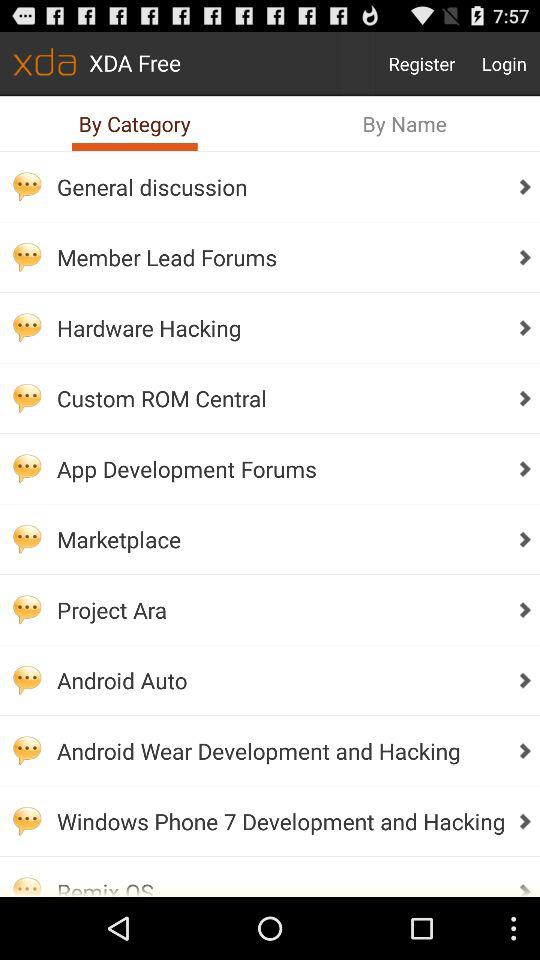What is the application name? The application name is "xda". 